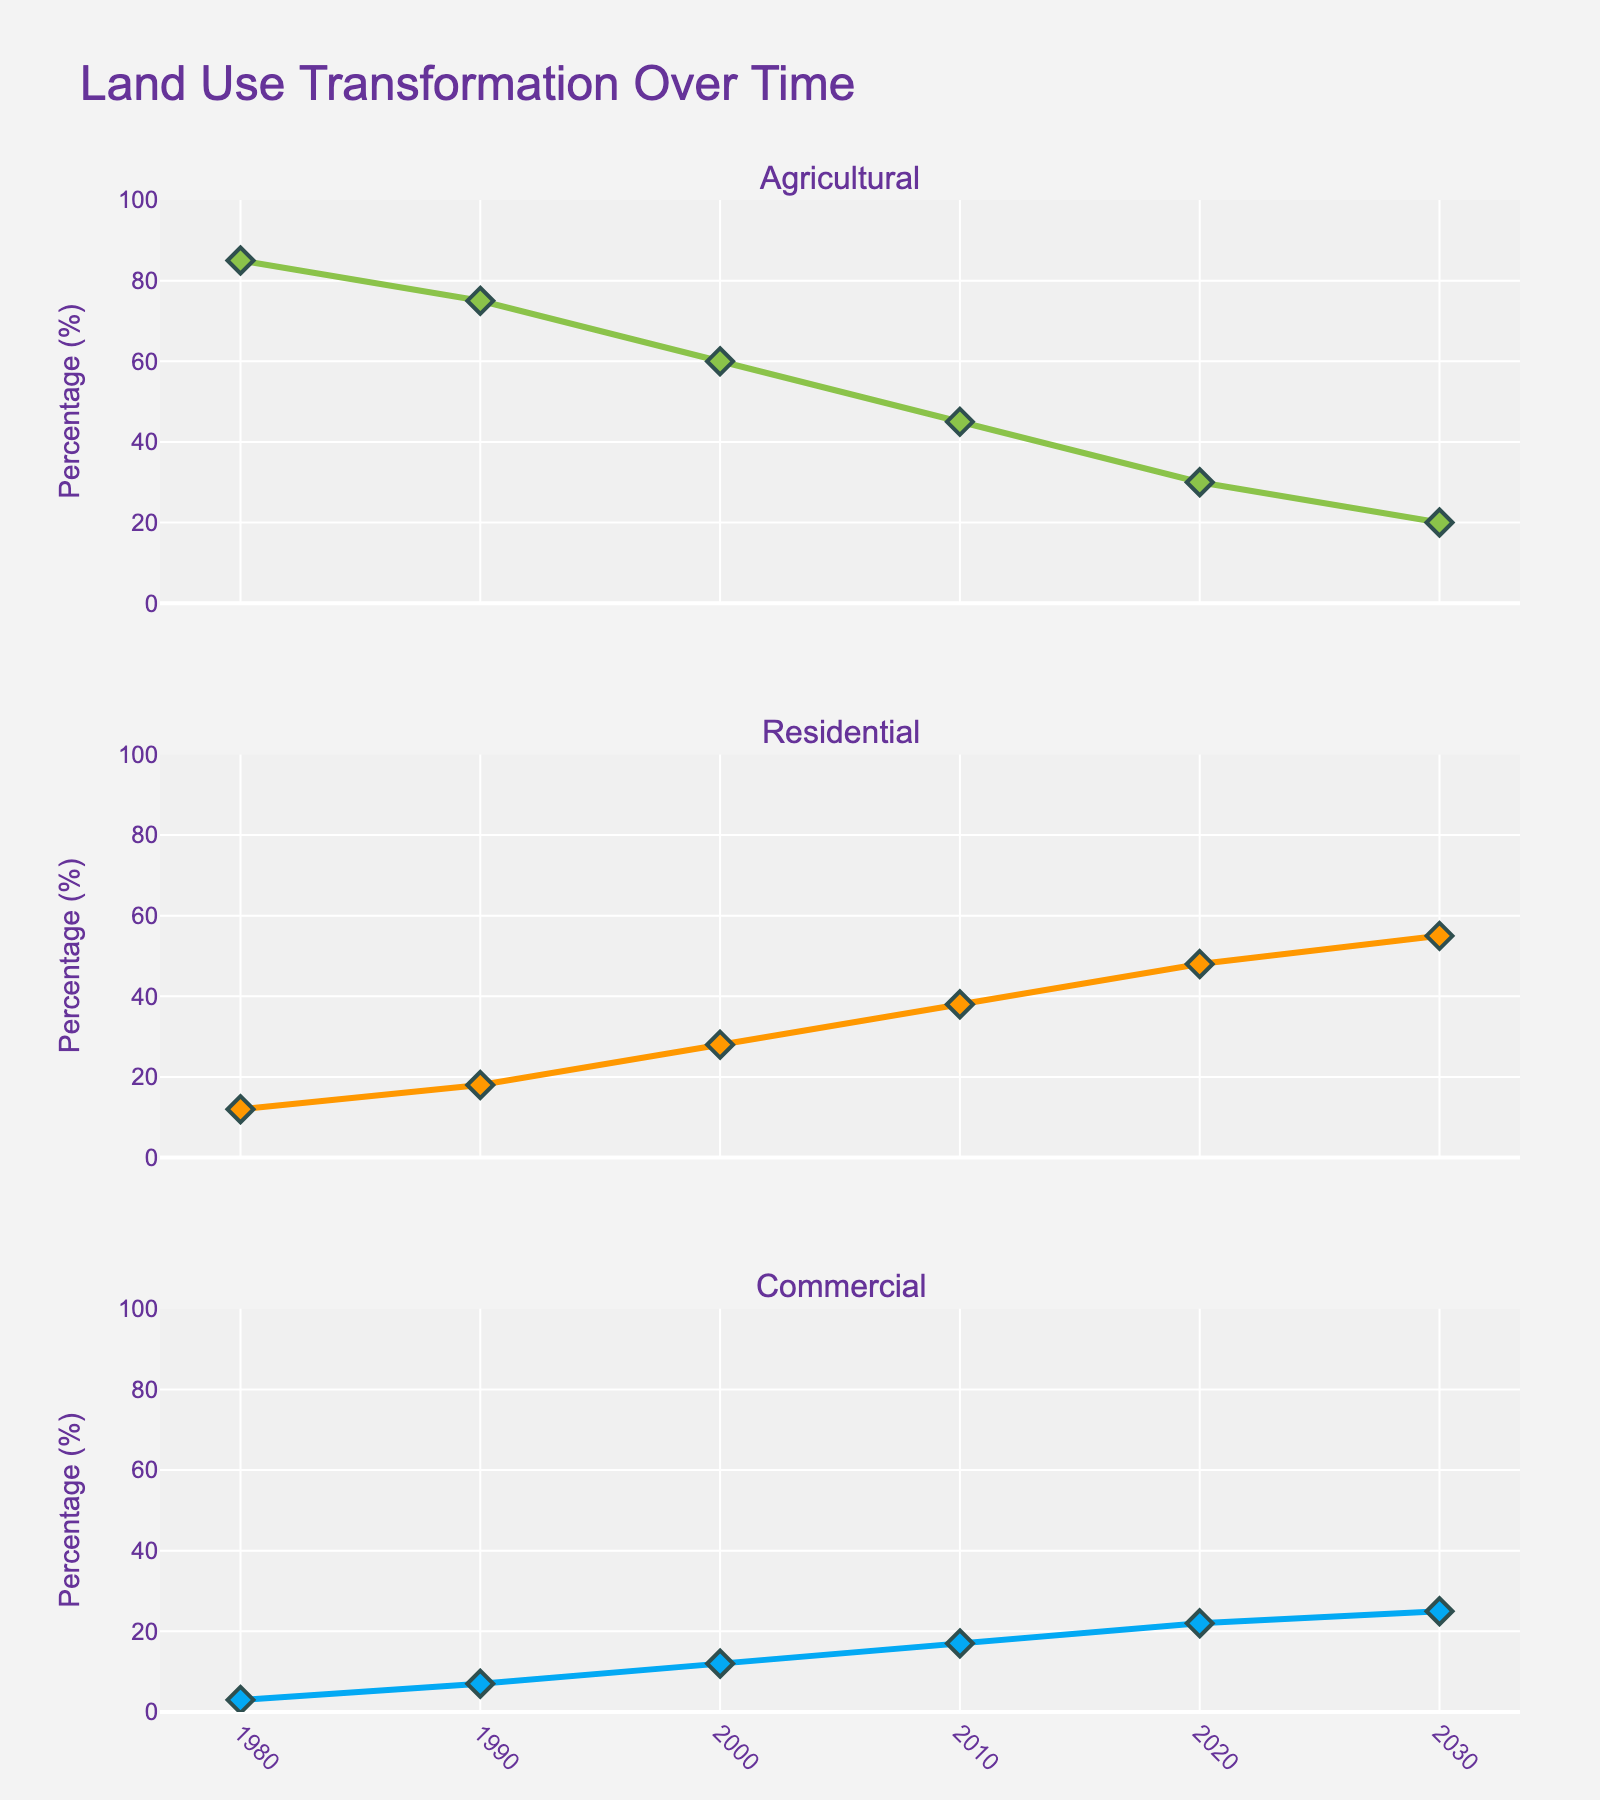How many firearms were analyzed based on the average accuracy scores? Count the distinct bars shown in the first subplot titled "Average Accuracy Scores". Each bar represents a firearm.
Answer: 10 Which firearm has the smallest grouping size in inches? Look at the scatter plot in the second subplot titled "Grouping Size vs. Shots Fired" and find the lowest value on the y-axis (Grouping Size). Hover over the points to identify the firearm with the smallest grouping size.
Answer: Ruger 10/22 How many shots were fired for the firearm with the highest average accuracy score? In the bar chart "Average Accuracy Scores", identify the bar with the highest value. Then, refer to the scatter plot "Grouping Size vs. Shots Fired" to find the corresponding firearm and its shots fired value.
Answer: 150 What proportion of firearms analyzed are manufactured by Sig Sauer? In the pie chart "Distribution of Firearm Types", identify the slice representing Sig Sauer and compute the proportion. There is only one Sig Sauer firearm out of a total of 10 firearms.
Answer: 10% Which caliber has the highest accuracy score with the least shooter experience? In the heatmap "Heatmap of Accuracy vs. Experience", identify the cell with the highest accuracy score and then locate the corresponding caliber and shooter experience on the axes.
Answer: .223 with 8 years What is the average grouping size in inches for the firearms with more than 5 years of shooter experience? Identify the points in the scatter plot "Grouping Size vs. Shots Fired" where the experience is more than 5 years, sum the grouping sizes, and divide by the number of such firearms.
Answer: (1.8 + 2.1 + 2.3 + 4.2) / 4 = 2.6 How does the shooter experience generally affect accuracy for the .308 Win caliber? Looking at the heatmap "Heatmap of Accuracy vs. Experience", focus on the cells corresponding to the .308 Win caliber and observe the change in accuracy scores as the shooter experience increases.
Answer: Accuracy tends to improve with more experience Which firearm model had both the highest number of shots fired and an above-average accuracy score? First, identify the firearm with the highest shots fired from the scatter plot. Then, check if its bar in the "Average Accuracy Scores" is above the average line.
Answer: Ruger 10/22 How does the grouping size for the Mossberg 500 compare to other 12 Gauge firearms? Compare the grouping size value for the Mossberg 500 in the scatter plot "Grouping Size vs. Shots Fired" against the grouping size for Benelli M4, the other 12 Gauge firearm.
Answer: Mossberg 500 has a larger grouping size compared to Benelli M4 